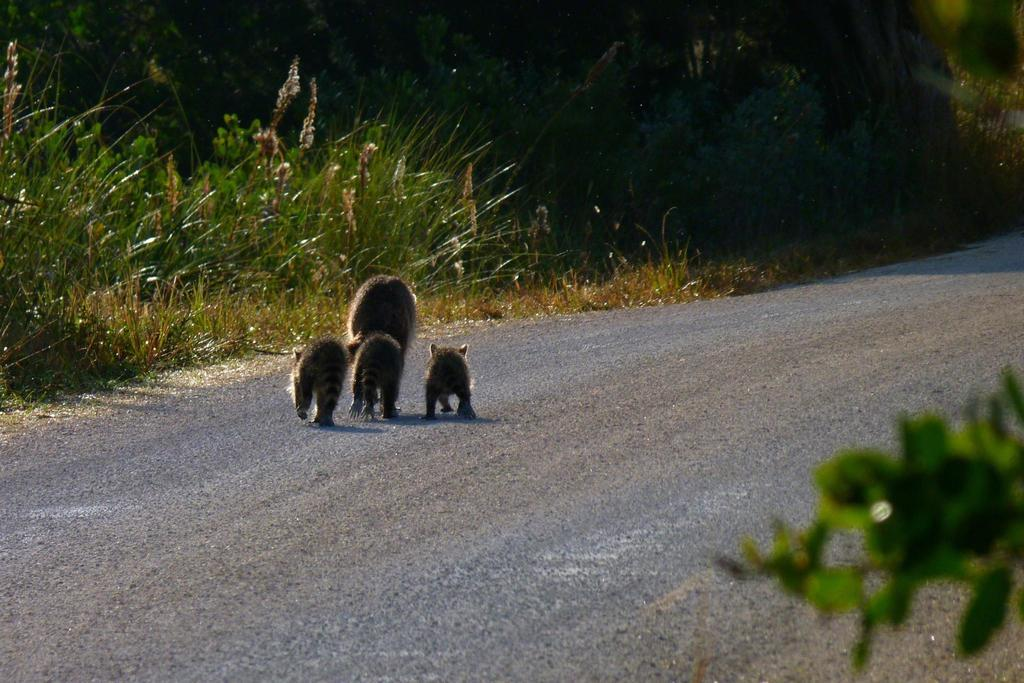What types of living organisms can be seen in the image? There are animals in the image. What colors are the animals in the image? The animals are in brown and black colors. What type of vegetation is visible in the image? There is green color grass in the image. What other natural elements can be seen in the image? There are trees in the image. What type of cover can be seen falling from the sky in the image? There is no cover or falling object visible in the image; it only features animals, grass, and trees. 